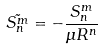<formula> <loc_0><loc_0><loc_500><loc_500>\tilde { S _ { n } ^ { m } } = - \frac { S _ { n } ^ { m } } { \mu R ^ { n } }</formula> 